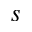Convert formula to latex. <formula><loc_0><loc_0><loc_500><loc_500>_ { s }</formula> 